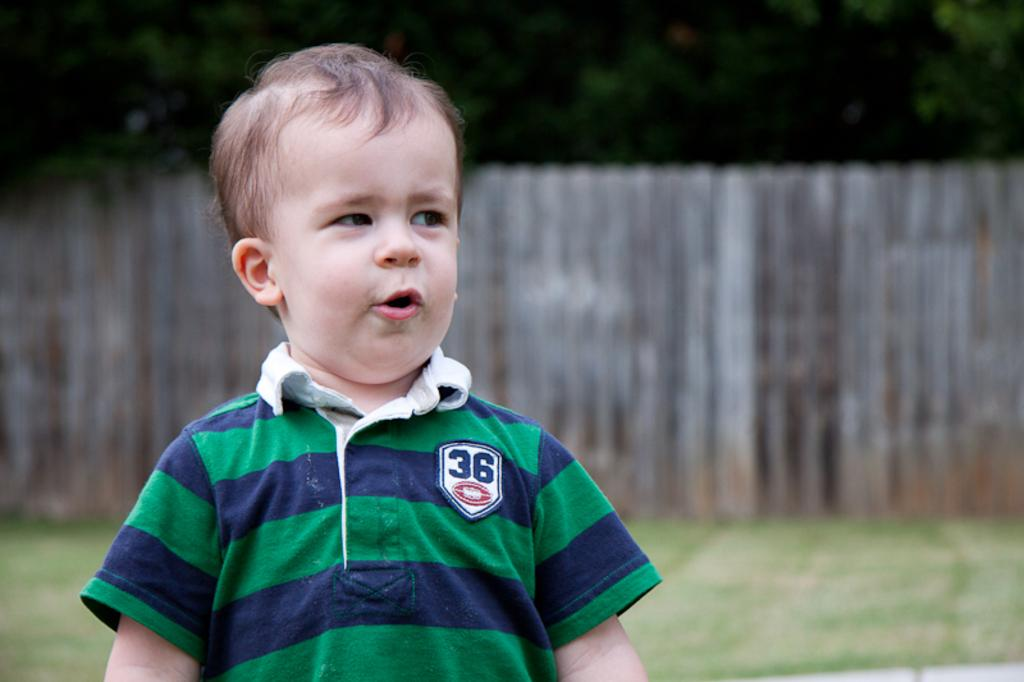<image>
Present a compact description of the photo's key features. a white small boy with blue and green lined t shirt and number 36 in his chest saying something. 